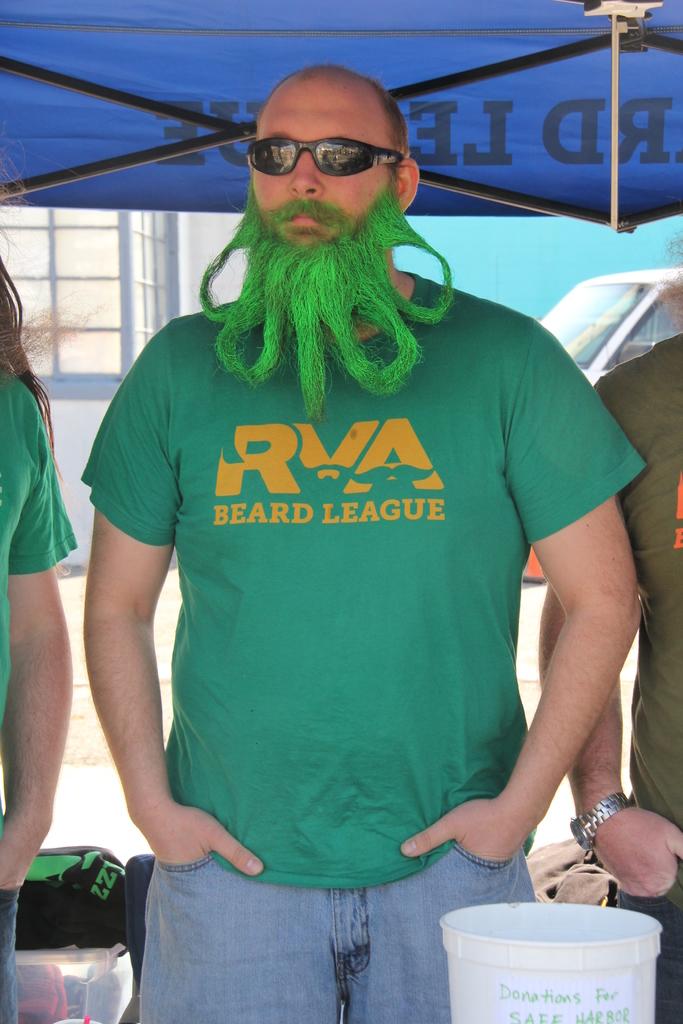What league is this?
Offer a terse response. Beard. 